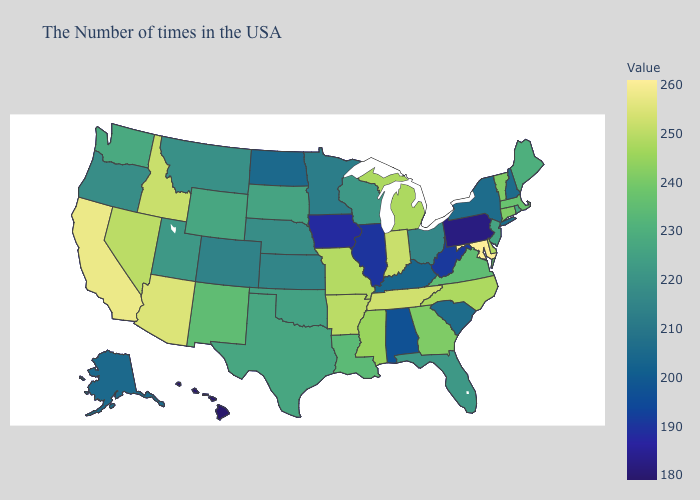Does Oklahoma have the lowest value in the USA?
Short answer required. No. Does Maryland have the highest value in the USA?
Keep it brief. Yes. Does Pennsylvania have the lowest value in the Northeast?
Short answer required. Yes. Does Utah have a lower value than Delaware?
Quick response, please. Yes. Does Oklahoma have the highest value in the South?
Answer briefly. No. Among the states that border Nebraska , which have the highest value?
Short answer required. Missouri. Among the states that border California , which have the highest value?
Answer briefly. Arizona. 